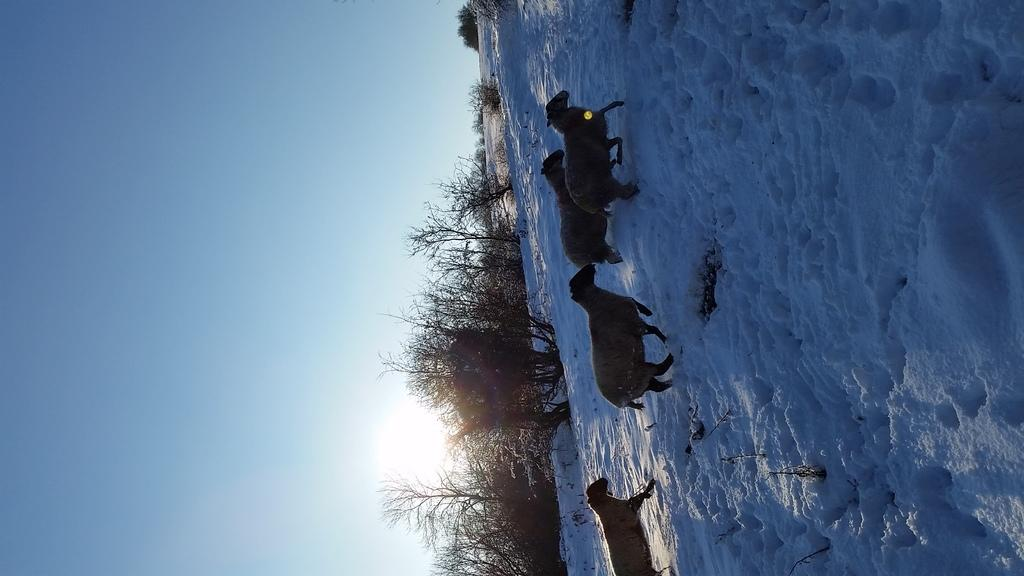How is the image oriented in relation to a typical photograph? The image is tilted. What part of the natural environment is visible in the image? There is sky visible in the image. What type of vegetation can be seen in the image? There are bare trees in the image. What type of animals are present in the image? There are animals in the image. What weather condition is suggested by the presence of snow in the image? There is snow in the image, which suggests a cold or wintry weather condition. What type of bells can be heard ringing in the image? There are no bells present in the image, and therefore no such sound can be heard. What type of earthquake can be seen happening in the image? There is no earthquake present in the image; it features a tilted landscape with sky, bare trees, animals, and snow. What type of digestion process is occurring in the animals in the image? There is no information provided about the digestion process of the animals in the image. 